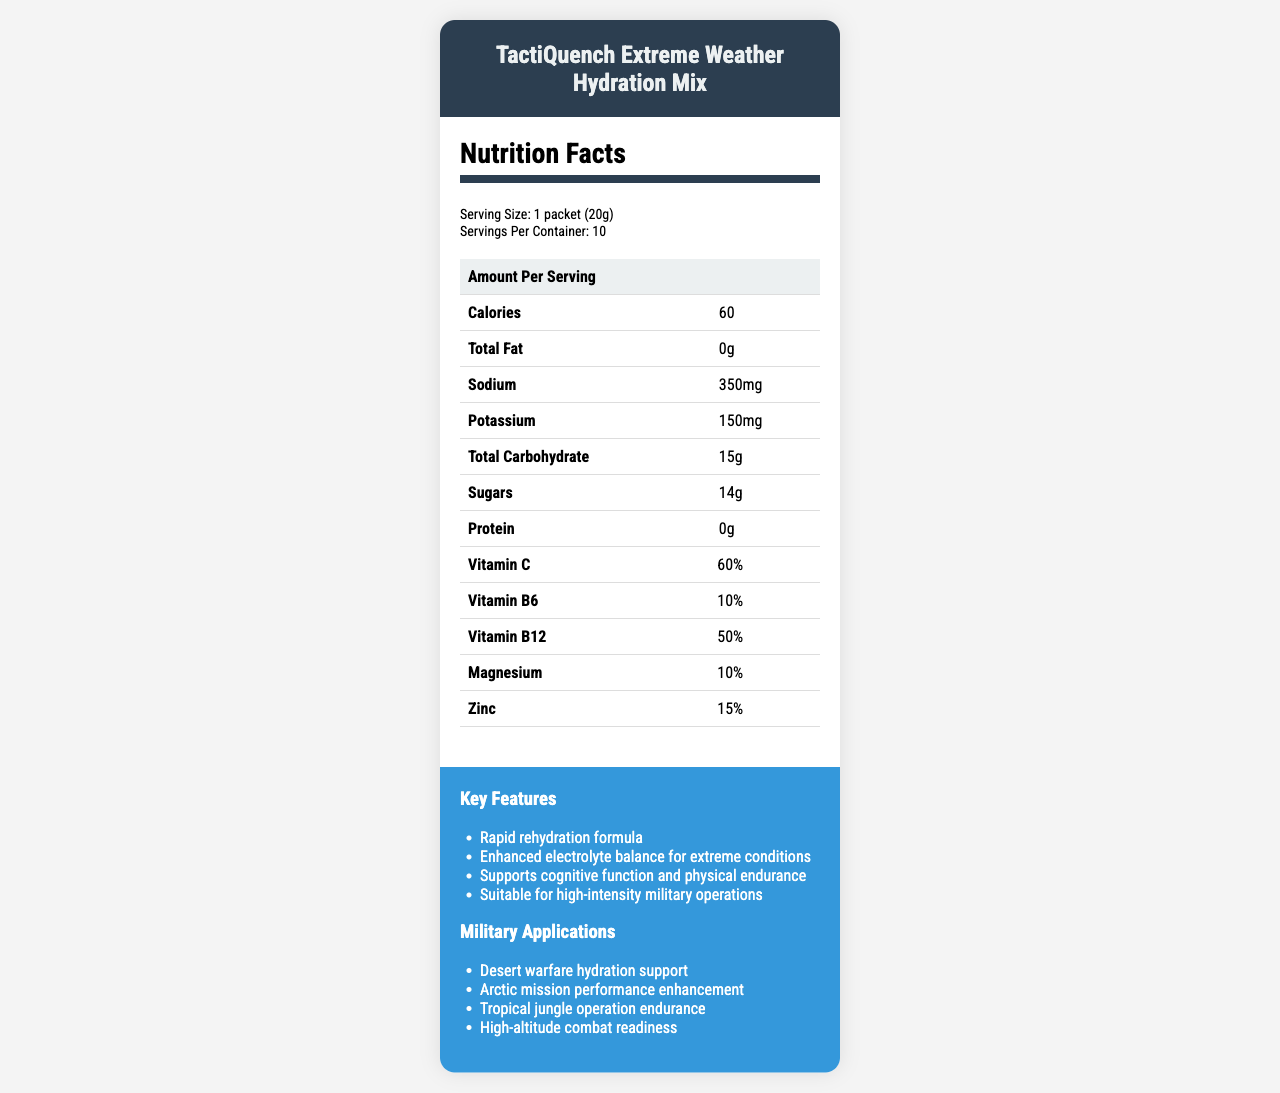what is the serving size of the TactiQuench Extreme Weather Hydration Mix? The serving size is explicitly stated in the 'Nutrition Facts' section.
Answer: 1 packet (20g) how many calories are in one serving of TactiQuench? The number of calories per serving is listed under the 'Amount Per Serving' section.
Answer: 60 how much sodium is in each serving? The amount of sodium per serving can be found in the 'Amount Per Serving' section under 'Sodium'.
Answer: 350mg how much sugar does the hydration mix contain per serving? The amount of sugar is listed under the 'Total Carbohydrate' section as a sub-item.
Answer: 14g which vitamin is present in the highest percentage in TactiQuench mix? The document shows that Vitamin B12 is at 50%, which is the highest percentage among all vitamins listed.
Answer: Vitamin B12 which of the following is NOT a key feature of TactiQuench mix?
A. Provides protein for muscle recovery
B. Rapid rehydration formula
C. Enhanced electrolyte balance for extreme conditions
D. Supports cognitive function and physical endurance Provides protein for muscle recovery is not listed as a key feature; the rest are mentioned as key features.
Answer: A what is the flavor of TactiQuench that is likely to be suitable for cold regions? 
I. Arctic Blast
II. Tropical Storm
III. Desert Mirage
IV. Mountain Peak Arctic Blast is the flavor that corresponds with cold regions.
Answer: I does the TactiQuench mix support hydration tracking integration with GPS systems? The document mentions that the product is compatible with GPS-enabled water consumption monitoring systems.
Answer: Yes summarize the main features and benefits of the TactiQuench Extreme Weather Hydration Mix The summary provides an overview of the product’s purpose, key nutritional facts, technological integration, and climate-specific packaging.
Answer: The TactiQuench Extreme Weather Hydration Mix is designed for extreme weather conditions. It includes a rapid rehydration formula with enhanced electrolyte balance, supports cognitive function and physical endurance, and is suitable for high-intensity military operations. Additional features include integration with hydration tracking technologies, tailored geospatial usage instructions, and availability in flavors suitable for different climates. Nutritional contents include key electrolytes, vitamins, and minimal calories and fat. what is the protein content in TactiQuench per serving? The protein content is listed under the 'Amount Per Serving' section as being 0 grams.
Answer: 0g which ingredients contribute to the color of TactiQuench mix? Beetroot Powder is specifically mentioned as being for color.
Answer: Beetroot Powder based on the document, can you tell how the formulation adjusts based on mission location data? The document mentions that the formulation adjusts based on mission location data, but it does not provide details on exactly how this adjustment is made.
Answer: Not enough information what are the four main climate zones mentioned for the color-coded packets of TactiQuench? The zones mentioned are included under geospatial considerations: Desert warfare hydration support, Arctic mission performance enhancement, Tropical jungle operation endurance, and High-altitude combat readiness.
Answer: Desert, Arctic, Tropical, High-altitude 